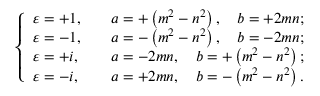Convert formula to latex. <formula><loc_0><loc_0><loc_500><loc_500>\left \{ \begin{array} { l l } { \varepsilon = + 1 , } & { \quad a = + \left ( m ^ { 2 } - n ^ { 2 } \right ) , \quad b = + 2 m n ; } \\ { \varepsilon = - 1 , } & { \quad a = - \left ( m ^ { 2 } - n ^ { 2 } \right ) , \quad b = - 2 m n ; } \\ { \varepsilon = + i , } & { \quad a = - 2 m n , \quad b = + \left ( m ^ { 2 } - n ^ { 2 } \right ) ; } \\ { \varepsilon = - i , } & { \quad a = + 2 m n , \quad b = - \left ( m ^ { 2 } - n ^ { 2 } \right ) . } \end{array}</formula> 